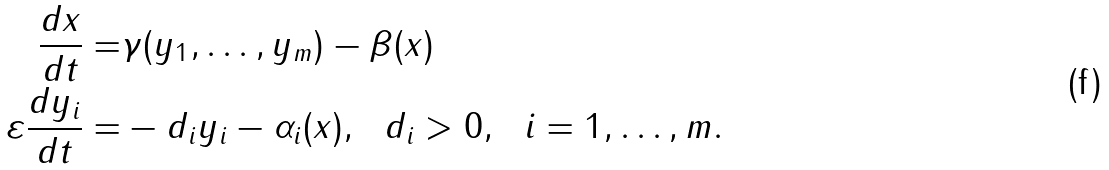<formula> <loc_0><loc_0><loc_500><loc_500>\frac { d x } { d t } = & \gamma ( y _ { 1 } , \dots , y _ { m } ) - \beta ( x ) \\ \varepsilon \frac { d y _ { i } } { d t } = & - d _ { i } y _ { i } - \alpha _ { i } ( x ) , \ \ d _ { i } > 0 , \ \ i = 1 , \dots , m .</formula> 